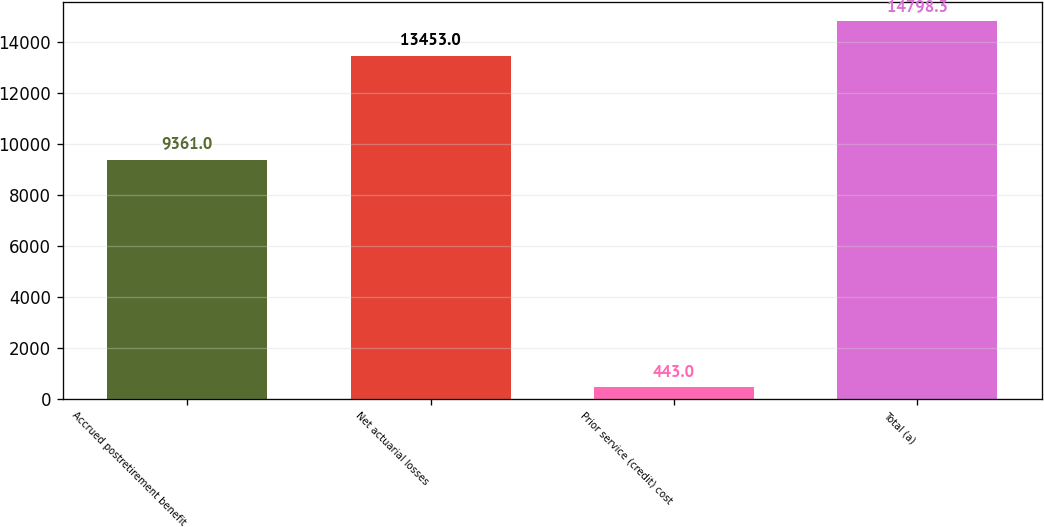Convert chart. <chart><loc_0><loc_0><loc_500><loc_500><bar_chart><fcel>Accrued postretirement benefit<fcel>Net actuarial losses<fcel>Prior service (credit) cost<fcel>Total (a)<nl><fcel>9361<fcel>13453<fcel>443<fcel>14798.3<nl></chart> 